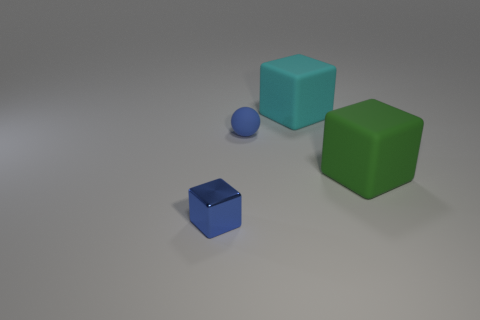Add 1 large green rubber blocks. How many objects exist? 5 Subtract all balls. How many objects are left? 3 Add 1 green objects. How many green objects exist? 2 Subtract 0 cyan cylinders. How many objects are left? 4 Subtract all gray spheres. Subtract all small spheres. How many objects are left? 3 Add 4 big matte blocks. How many big matte blocks are left? 6 